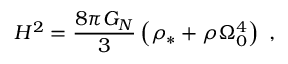Convert formula to latex. <formula><loc_0><loc_0><loc_500><loc_500>H ^ { 2 } = \frac { 8 \pi G _ { N } } { 3 } \left ( \rho _ { * } + \rho \Omega _ { 0 } ^ { 4 } \right ) ,</formula> 